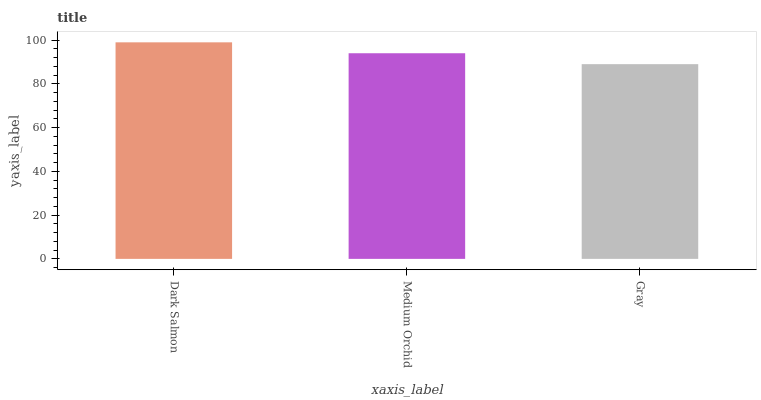Is Gray the minimum?
Answer yes or no. Yes. Is Dark Salmon the maximum?
Answer yes or no. Yes. Is Medium Orchid the minimum?
Answer yes or no. No. Is Medium Orchid the maximum?
Answer yes or no. No. Is Dark Salmon greater than Medium Orchid?
Answer yes or no. Yes. Is Medium Orchid less than Dark Salmon?
Answer yes or no. Yes. Is Medium Orchid greater than Dark Salmon?
Answer yes or no. No. Is Dark Salmon less than Medium Orchid?
Answer yes or no. No. Is Medium Orchid the high median?
Answer yes or no. Yes. Is Medium Orchid the low median?
Answer yes or no. Yes. Is Dark Salmon the high median?
Answer yes or no. No. Is Gray the low median?
Answer yes or no. No. 